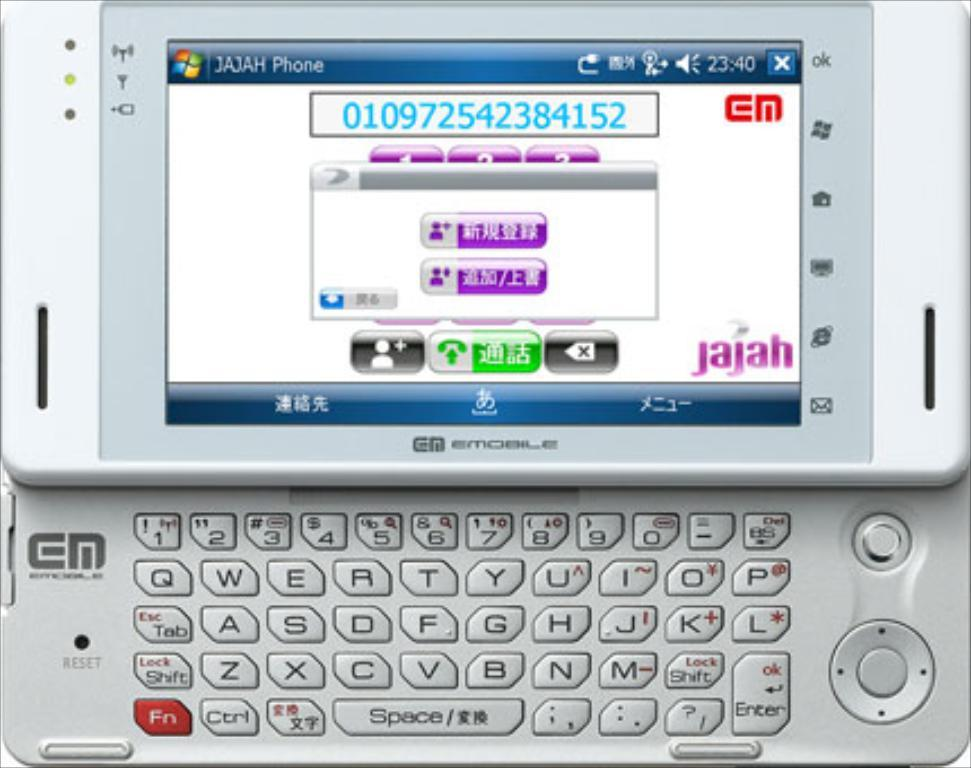<image>
Give a short and clear explanation of the subsequent image. A JAJAH EMobile phone with a full slide-out keyboard and a screen displaying the number 010972542384152. 